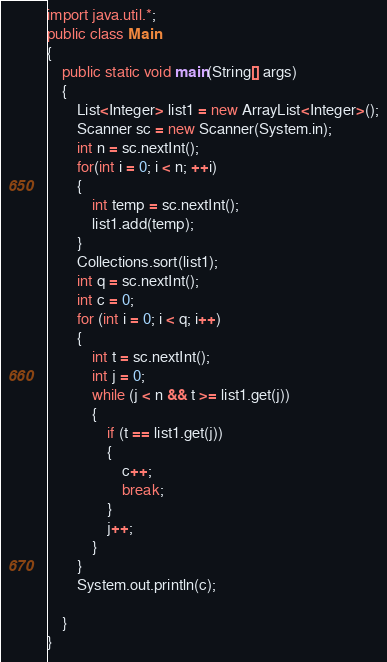<code> <loc_0><loc_0><loc_500><loc_500><_Java_>import java.util.*;
public class Main 
{	
	public static void main(String[] args) 
	{
		List<Integer> list1 = new ArrayList<Integer>();
		Scanner sc = new Scanner(System.in);
		int n = sc.nextInt();
		for(int i = 0; i < n; ++i)
		{
			int temp = sc.nextInt();
			list1.add(temp);
		}
		Collections.sort(list1);
		int q = sc.nextInt();
		int c = 0;
		for (int i = 0; i < q; i++)
		{
			int t = sc.nextInt();
			int j = 0;
			while (j < n && t >= list1.get(j))
			{
				if (t == list1.get(j))
				{
					c++;
					break;
				}
				j++;
			}
		}
		System.out.println(c);

	}
}</code> 